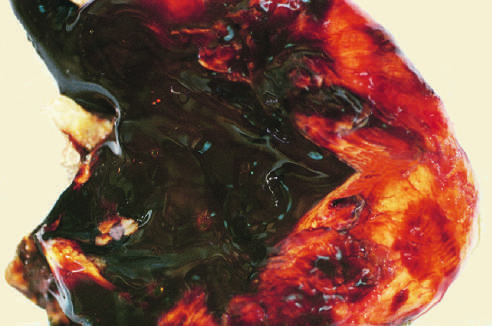what does sectioning of ovary show?
Answer the question using a single word or phrase. Large endometriotic cyst with degenerated blood 